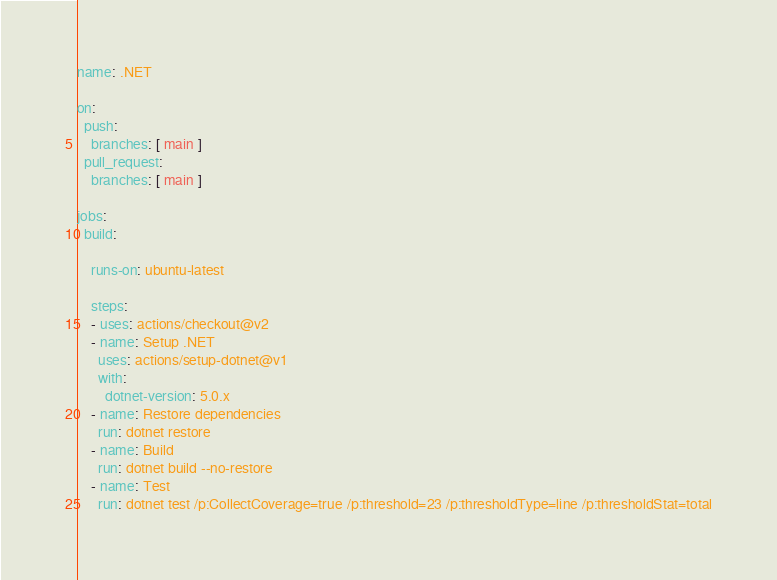<code> <loc_0><loc_0><loc_500><loc_500><_YAML_>name: .NET

on:
  push:
    branches: [ main ]
  pull_request:
    branches: [ main ]

jobs:
  build:

    runs-on: ubuntu-latest

    steps:
    - uses: actions/checkout@v2
    - name: Setup .NET
      uses: actions/setup-dotnet@v1
      with:
        dotnet-version: 5.0.x
    - name: Restore dependencies
      run: dotnet restore
    - name: Build
      run: dotnet build --no-restore
    - name: Test
      run: dotnet test /p:CollectCoverage=true /p:threshold=23 /p:thresholdType=line /p:thresholdStat=total
</code> 